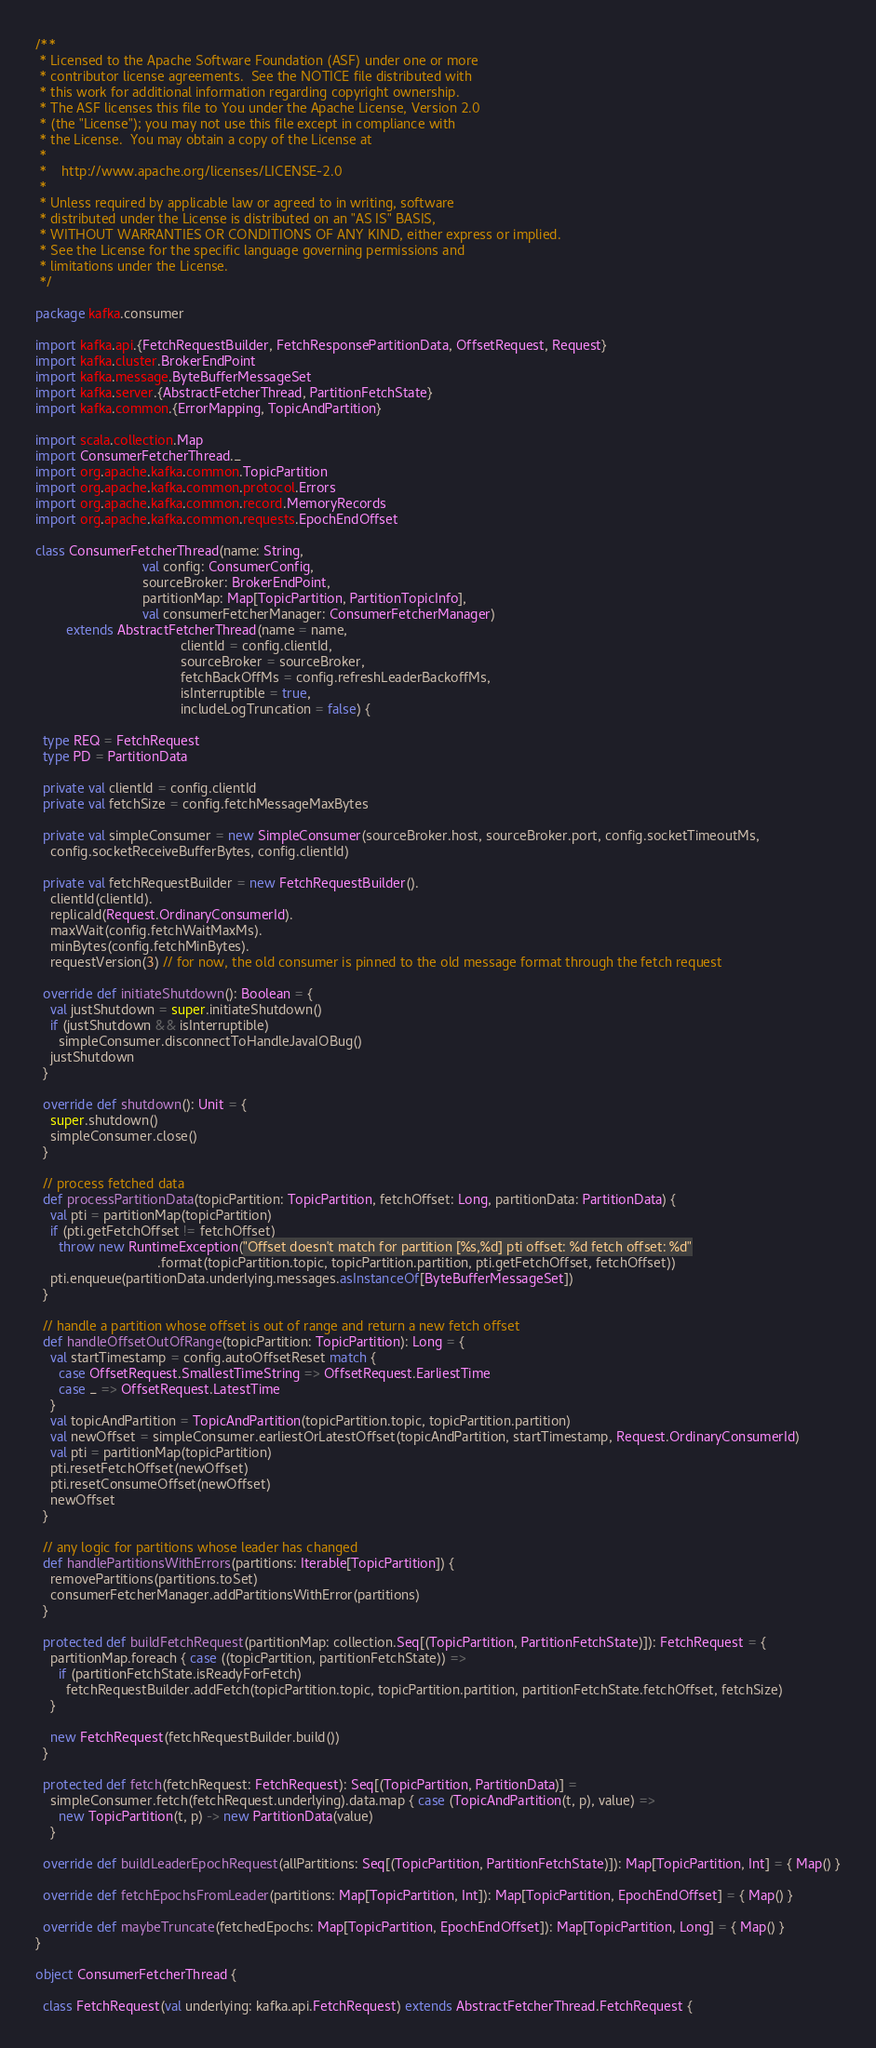<code> <loc_0><loc_0><loc_500><loc_500><_Scala_>/**
 * Licensed to the Apache Software Foundation (ASF) under one or more
 * contributor license agreements.  See the NOTICE file distributed with
 * this work for additional information regarding copyright ownership.
 * The ASF licenses this file to You under the Apache License, Version 2.0
 * (the "License"); you may not use this file except in compliance with
 * the License.  You may obtain a copy of the License at
 *
 *    http://www.apache.org/licenses/LICENSE-2.0
 *
 * Unless required by applicable law or agreed to in writing, software
 * distributed under the License is distributed on an "AS IS" BASIS,
 * WITHOUT WARRANTIES OR CONDITIONS OF ANY KIND, either express or implied.
 * See the License for the specific language governing permissions and
 * limitations under the License.
 */

package kafka.consumer

import kafka.api.{FetchRequestBuilder, FetchResponsePartitionData, OffsetRequest, Request}
import kafka.cluster.BrokerEndPoint
import kafka.message.ByteBufferMessageSet
import kafka.server.{AbstractFetcherThread, PartitionFetchState}
import kafka.common.{ErrorMapping, TopicAndPartition}

import scala.collection.Map
import ConsumerFetcherThread._
import org.apache.kafka.common.TopicPartition
import org.apache.kafka.common.protocol.Errors
import org.apache.kafka.common.record.MemoryRecords
import org.apache.kafka.common.requests.EpochEndOffset

class ConsumerFetcherThread(name: String,
                            val config: ConsumerConfig,
                            sourceBroker: BrokerEndPoint,
                            partitionMap: Map[TopicPartition, PartitionTopicInfo],
                            val consumerFetcherManager: ConsumerFetcherManager)
        extends AbstractFetcherThread(name = name,
                                      clientId = config.clientId,
                                      sourceBroker = sourceBroker,
                                      fetchBackOffMs = config.refreshLeaderBackoffMs,
                                      isInterruptible = true,
                                      includeLogTruncation = false) {

  type REQ = FetchRequest
  type PD = PartitionData

  private val clientId = config.clientId
  private val fetchSize = config.fetchMessageMaxBytes

  private val simpleConsumer = new SimpleConsumer(sourceBroker.host, sourceBroker.port, config.socketTimeoutMs,
    config.socketReceiveBufferBytes, config.clientId)

  private val fetchRequestBuilder = new FetchRequestBuilder().
    clientId(clientId).
    replicaId(Request.OrdinaryConsumerId).
    maxWait(config.fetchWaitMaxMs).
    minBytes(config.fetchMinBytes).
    requestVersion(3) // for now, the old consumer is pinned to the old message format through the fetch request

  override def initiateShutdown(): Boolean = {
    val justShutdown = super.initiateShutdown()
    if (justShutdown && isInterruptible)
      simpleConsumer.disconnectToHandleJavaIOBug()
    justShutdown
  }

  override def shutdown(): Unit = {
    super.shutdown()
    simpleConsumer.close()
  }

  // process fetched data
  def processPartitionData(topicPartition: TopicPartition, fetchOffset: Long, partitionData: PartitionData) {
    val pti = partitionMap(topicPartition)
    if (pti.getFetchOffset != fetchOffset)
      throw new RuntimeException("Offset doesn't match for partition [%s,%d] pti offset: %d fetch offset: %d"
                                .format(topicPartition.topic, topicPartition.partition, pti.getFetchOffset, fetchOffset))
    pti.enqueue(partitionData.underlying.messages.asInstanceOf[ByteBufferMessageSet])
  }

  // handle a partition whose offset is out of range and return a new fetch offset
  def handleOffsetOutOfRange(topicPartition: TopicPartition): Long = {
    val startTimestamp = config.autoOffsetReset match {
      case OffsetRequest.SmallestTimeString => OffsetRequest.EarliestTime
      case _ => OffsetRequest.LatestTime
    }
    val topicAndPartition = TopicAndPartition(topicPartition.topic, topicPartition.partition)
    val newOffset = simpleConsumer.earliestOrLatestOffset(topicAndPartition, startTimestamp, Request.OrdinaryConsumerId)
    val pti = partitionMap(topicPartition)
    pti.resetFetchOffset(newOffset)
    pti.resetConsumeOffset(newOffset)
    newOffset
  }

  // any logic for partitions whose leader has changed
  def handlePartitionsWithErrors(partitions: Iterable[TopicPartition]) {
    removePartitions(partitions.toSet)
    consumerFetcherManager.addPartitionsWithError(partitions)
  }

  protected def buildFetchRequest(partitionMap: collection.Seq[(TopicPartition, PartitionFetchState)]): FetchRequest = {
    partitionMap.foreach { case ((topicPartition, partitionFetchState)) =>
      if (partitionFetchState.isReadyForFetch)
        fetchRequestBuilder.addFetch(topicPartition.topic, topicPartition.partition, partitionFetchState.fetchOffset, fetchSize)
    }

    new FetchRequest(fetchRequestBuilder.build())
  }

  protected def fetch(fetchRequest: FetchRequest): Seq[(TopicPartition, PartitionData)] =
    simpleConsumer.fetch(fetchRequest.underlying).data.map { case (TopicAndPartition(t, p), value) =>
      new TopicPartition(t, p) -> new PartitionData(value)
    }

  override def buildLeaderEpochRequest(allPartitions: Seq[(TopicPartition, PartitionFetchState)]): Map[TopicPartition, Int] = { Map() }

  override def fetchEpochsFromLeader(partitions: Map[TopicPartition, Int]): Map[TopicPartition, EpochEndOffset] = { Map() }

  override def maybeTruncate(fetchedEpochs: Map[TopicPartition, EpochEndOffset]): Map[TopicPartition, Long] = { Map() }
}

object ConsumerFetcherThread {

  class FetchRequest(val underlying: kafka.api.FetchRequest) extends AbstractFetcherThread.FetchRequest {</code> 